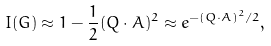Convert formula to latex. <formula><loc_0><loc_0><loc_500><loc_500>I ( { G } ) \approx 1 - \frac { 1 } { 2 } ( { Q } \cdot { A } ) ^ { 2 } \approx e ^ { - ( { Q } \cdot { A } ) ^ { 2 } / 2 } ,</formula> 